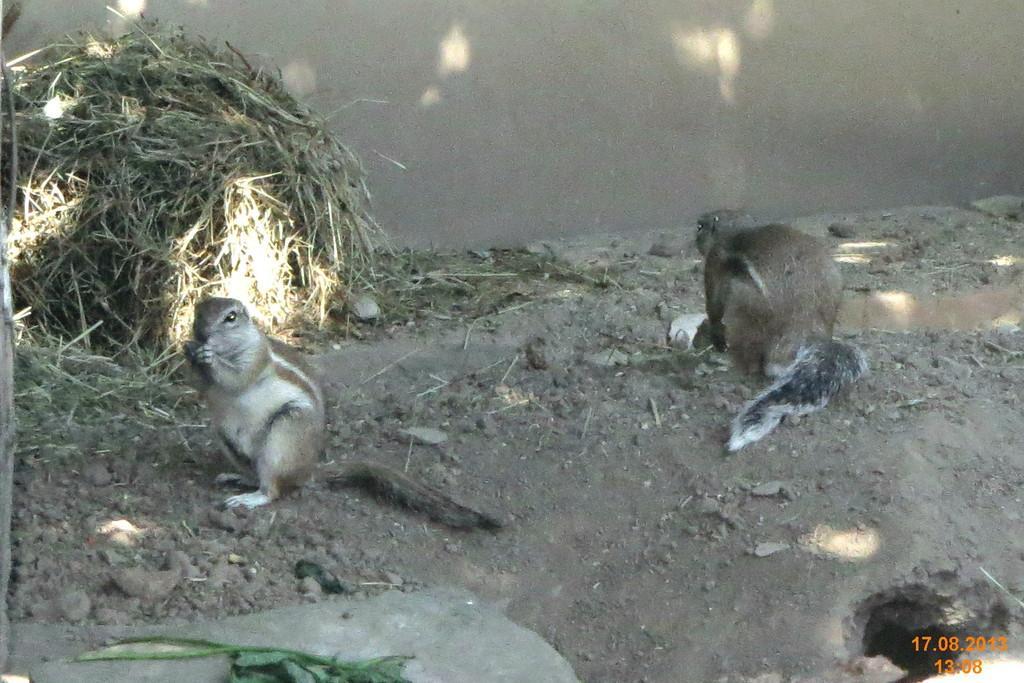Describe this image in one or two sentences. In this image there are squirrels. At the bottom there is a rock. On the right we can see a burrow. In the background there is grass and a wall. 